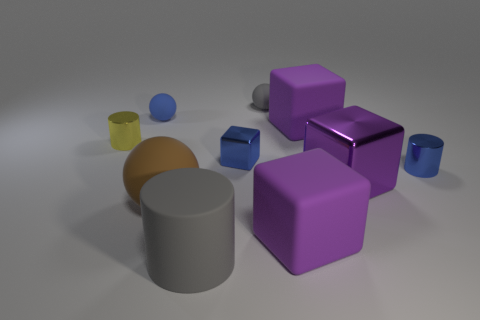Subtract all purple cylinders. How many purple cubes are left? 3 Subtract all big purple cubes. How many cubes are left? 1 Subtract all blue cubes. How many cubes are left? 3 Subtract all yellow blocks. Subtract all green cylinders. How many blocks are left? 4 Subtract all cylinders. How many objects are left? 7 Add 3 tiny spheres. How many tiny spheres exist? 5 Subtract 1 gray balls. How many objects are left? 9 Subtract all gray objects. Subtract all small red balls. How many objects are left? 8 Add 8 gray objects. How many gray objects are left? 10 